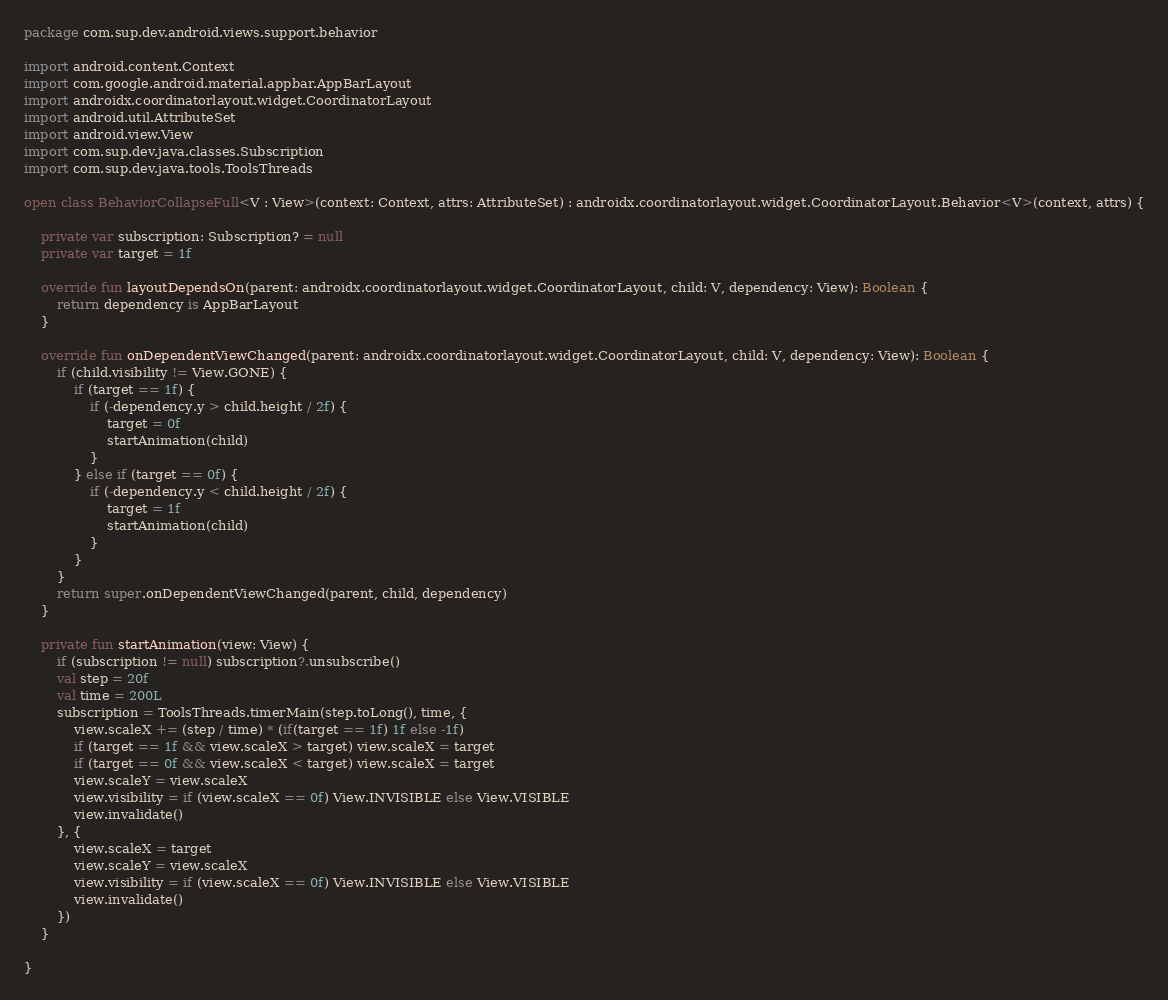<code> <loc_0><loc_0><loc_500><loc_500><_Kotlin_>package com.sup.dev.android.views.support.behavior

import android.content.Context
import com.google.android.material.appbar.AppBarLayout
import androidx.coordinatorlayout.widget.CoordinatorLayout
import android.util.AttributeSet
import android.view.View
import com.sup.dev.java.classes.Subscription
import com.sup.dev.java.tools.ToolsThreads

open class BehaviorCollapseFull<V : View>(context: Context, attrs: AttributeSet) : androidx.coordinatorlayout.widget.CoordinatorLayout.Behavior<V>(context, attrs) {

    private var subscription: Subscription? = null
    private var target = 1f

    override fun layoutDependsOn(parent: androidx.coordinatorlayout.widget.CoordinatorLayout, child: V, dependency: View): Boolean {
        return dependency is AppBarLayout
    }

    override fun onDependentViewChanged(parent: androidx.coordinatorlayout.widget.CoordinatorLayout, child: V, dependency: View): Boolean {
        if (child.visibility != View.GONE) {
            if (target == 1f) {
                if (-dependency.y > child.height / 2f) {
                    target = 0f
                    startAnimation(child)
                }
            } else if (target == 0f) {
                if (-dependency.y < child.height / 2f) {
                    target = 1f
                    startAnimation(child)
                }
            }
        }
        return super.onDependentViewChanged(parent, child, dependency)
    }

    private fun startAnimation(view: View) {
        if (subscription != null) subscription?.unsubscribe()
        val step = 20f
        val time = 200L
        subscription = ToolsThreads.timerMain(step.toLong(), time, {
            view.scaleX += (step / time) * (if(target == 1f) 1f else -1f)
            if (target == 1f && view.scaleX > target) view.scaleX = target
            if (target == 0f && view.scaleX < target) view.scaleX = target
            view.scaleY = view.scaleX
            view.visibility = if (view.scaleX == 0f) View.INVISIBLE else View.VISIBLE
            view.invalidate()
        }, {
            view.scaleX = target
            view.scaleY = view.scaleX
            view.visibility = if (view.scaleX == 0f) View.INVISIBLE else View.VISIBLE
            view.invalidate()
        })
    }

}</code> 